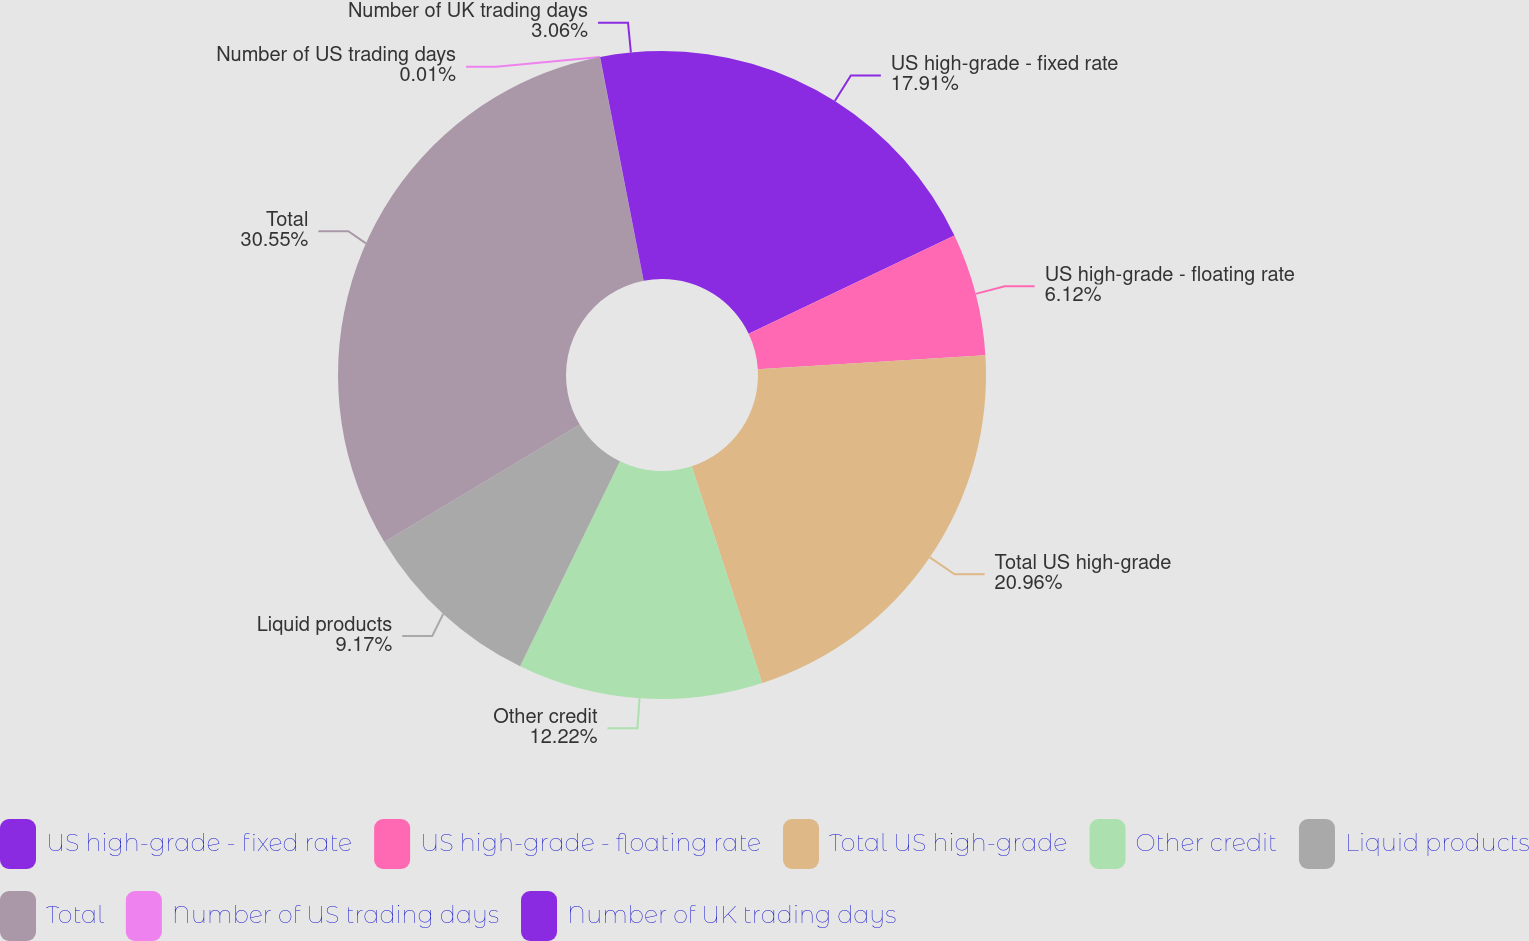Convert chart. <chart><loc_0><loc_0><loc_500><loc_500><pie_chart><fcel>US high-grade - fixed rate<fcel>US high-grade - floating rate<fcel>Total US high-grade<fcel>Other credit<fcel>Liquid products<fcel>Total<fcel>Number of US trading days<fcel>Number of UK trading days<nl><fcel>17.91%<fcel>6.12%<fcel>20.96%<fcel>12.22%<fcel>9.17%<fcel>30.54%<fcel>0.01%<fcel>3.06%<nl></chart> 